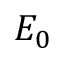Convert formula to latex. <formula><loc_0><loc_0><loc_500><loc_500>E _ { 0 }</formula> 